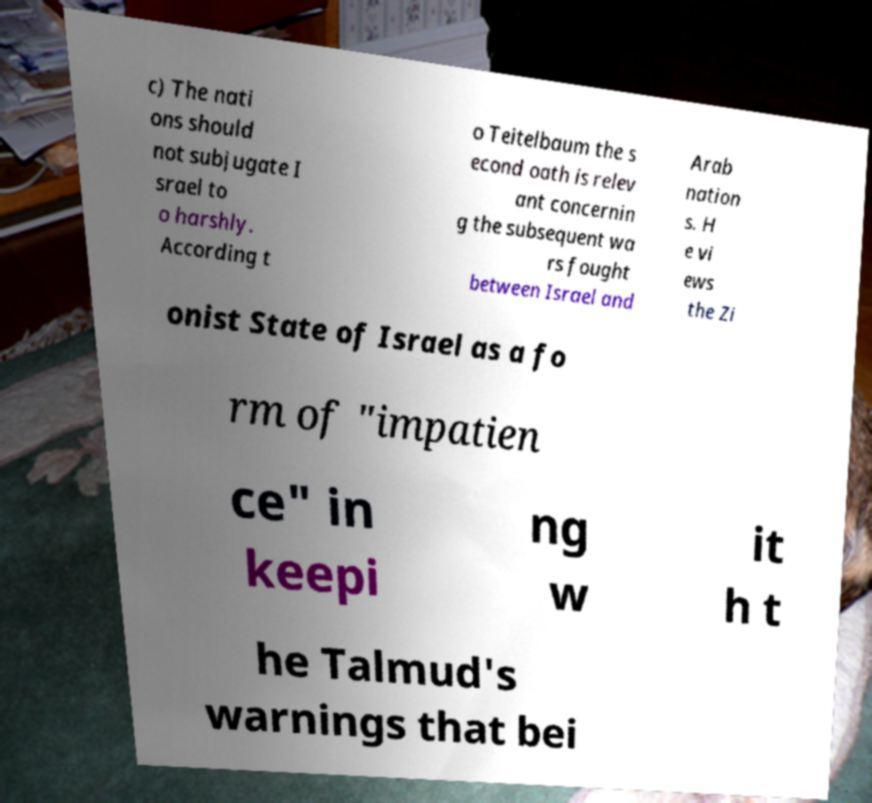For documentation purposes, I need the text within this image transcribed. Could you provide that? c) The nati ons should not subjugate I srael to o harshly. According t o Teitelbaum the s econd oath is relev ant concernin g the subsequent wa rs fought between Israel and Arab nation s. H e vi ews the Zi onist State of Israel as a fo rm of "impatien ce" in keepi ng w it h t he Talmud's warnings that bei 